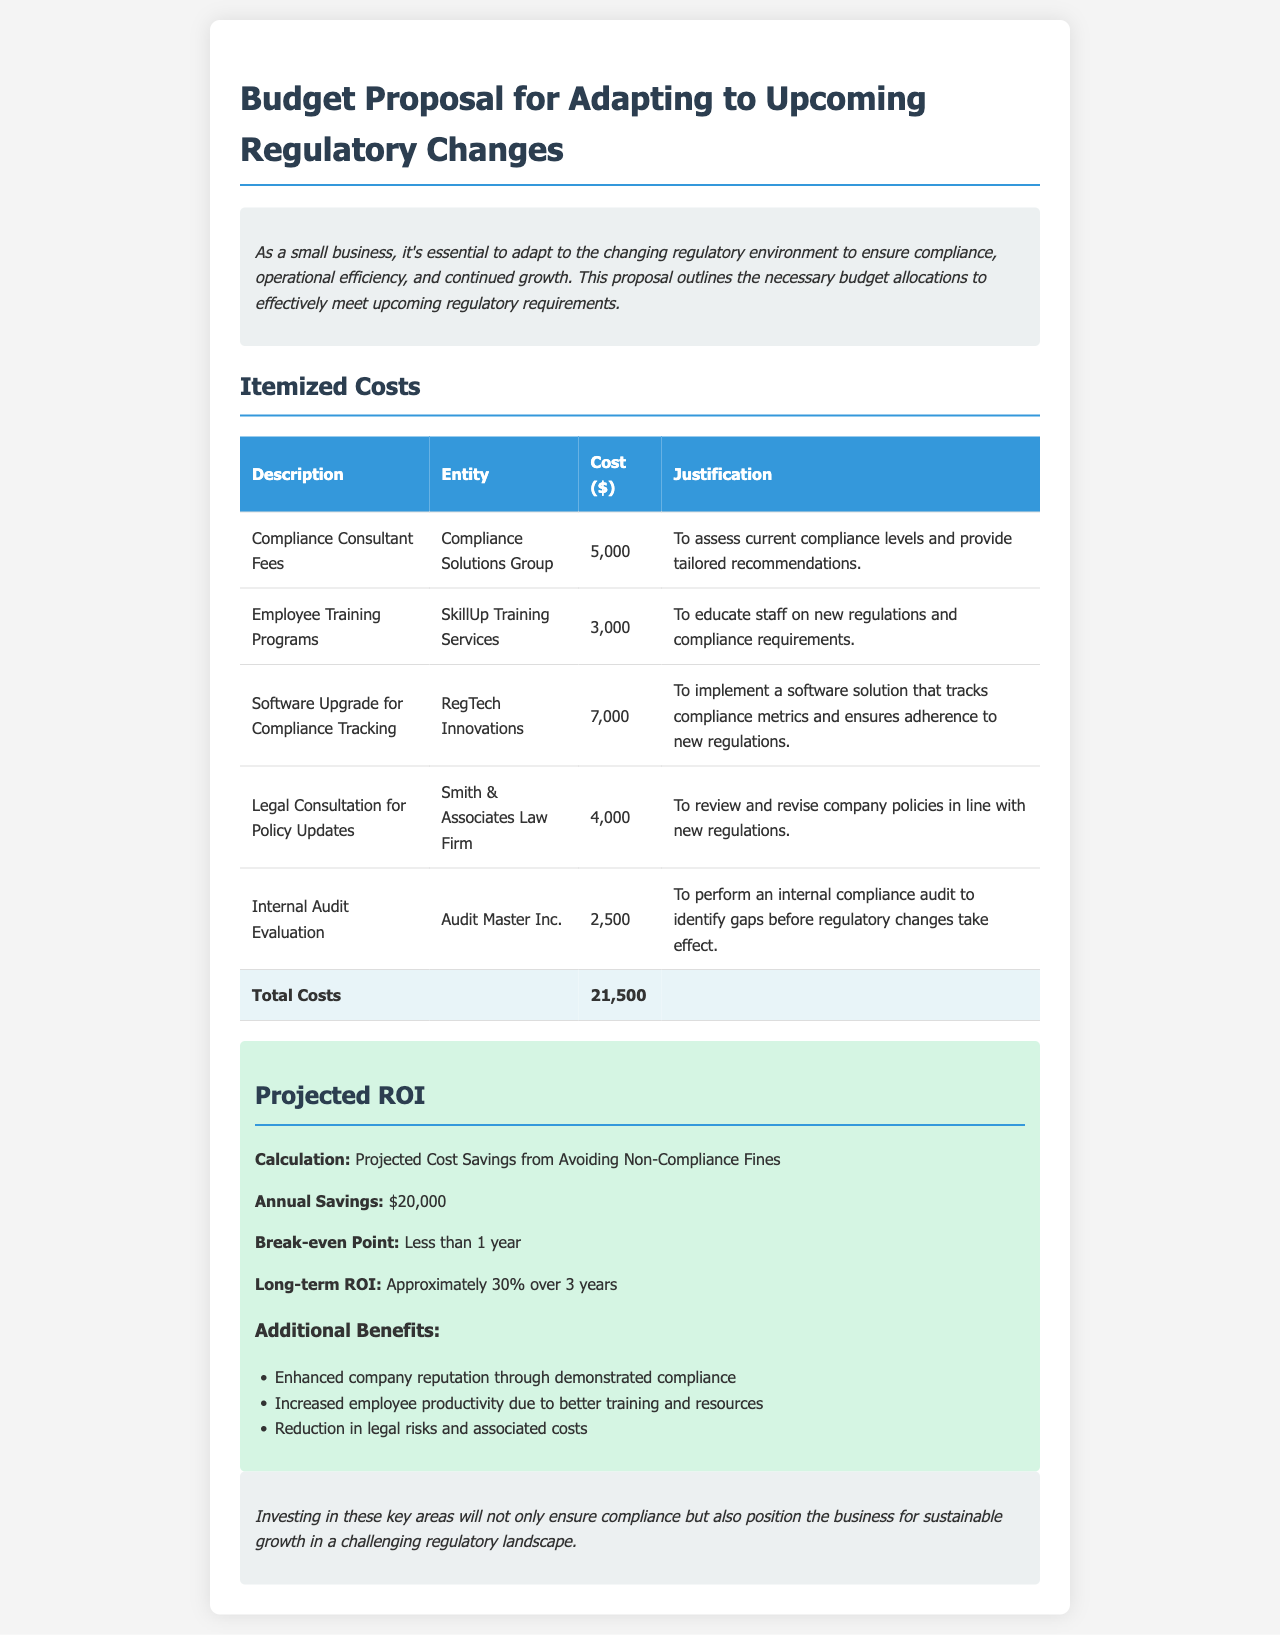what is the total cost for the proposed budget? The total cost is calculated from the itemized costs listed in the document under "Total Costs," which is $21,500.
Answer: $21,500 who is providing the compliance consultant services? The entity providing the compliance consultant services is mentioned in the itemized costs under "Entity."
Answer: Compliance Solutions Group how much is allocated for employee training programs? The allocation for employee training programs is listed in the itemized costs under "Cost."
Answer: $3,000 what is the annual savings projected from avoiding non-compliance fines? The annual savings is specified under the "Projected ROI" section, detailing the cost savings from compliance efforts.
Answer: $20,000 what will be the break-even point for the investment? The break-even point is indicated in the "Projected ROI" section, which says it will be less than 1 year.
Answer: Less than 1 year how many items are listed in the itemized costs? The number of items listed is counted in the itemized costs table under "Description."
Answer: 5 items what is one long-term benefit mentioned in the document? One long-term benefit mentioned in the document is indicated in the "Additional Benefits" section.
Answer: Enhanced company reputation what is the total number of hours estimated for the internal audit evaluation? The document does not specify the number of hours for the internal audit evaluation, as it only mentions the cost involved.
Answer: Not specified what service is provided by the legal consultation? The specific service provided by the legal consultation is stated in the justification under "Legal Consultation for Policy Updates."
Answer: Review and revise company policies 